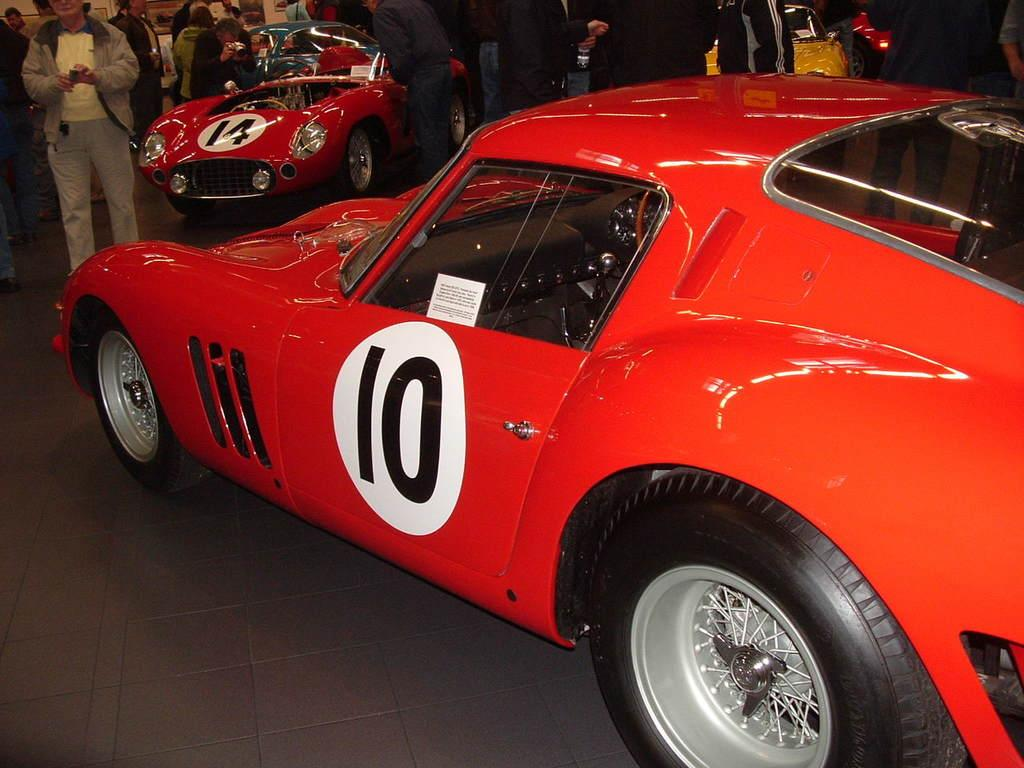Who or what can be seen in the image? There are people in the image. What type of vehicles are present in the image? There are red color cars and a yellow car in the image. What event might the image be capturing? The image was taken at a car exhibition. Can you see any beetles flying around the yellow car in the image? There are no beetles visible in the image, as it primarily features people and cars at a car exhibition. 